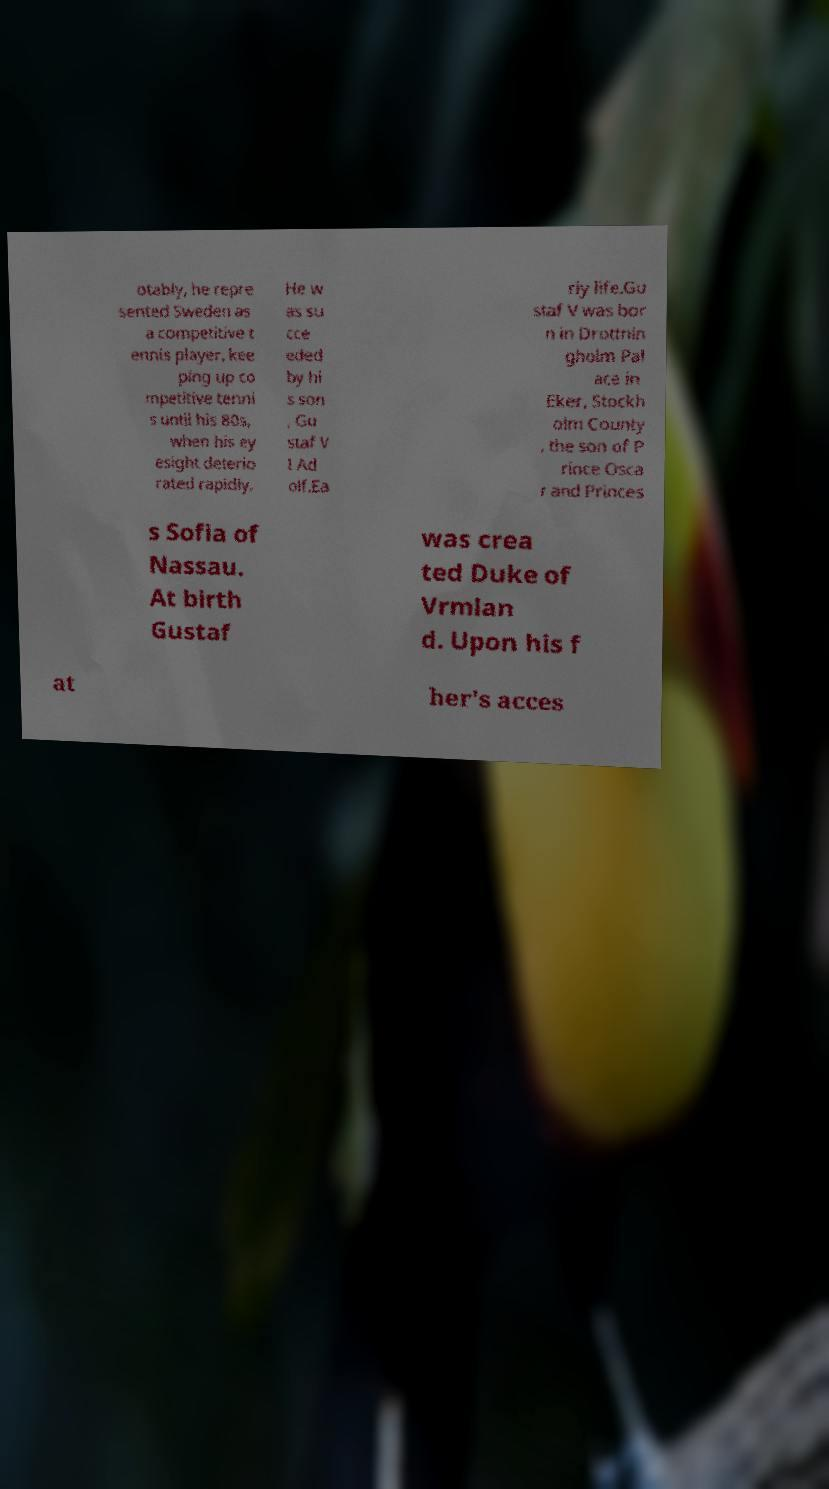What messages or text are displayed in this image? I need them in a readable, typed format. otably, he repre sented Sweden as a competitive t ennis player, kee ping up co mpetitive tenni s until his 80s, when his ey esight deterio rated rapidly. He w as su cce eded by hi s son , Gu staf V I Ad olf.Ea rly life.Gu staf V was bor n in Drottnin gholm Pal ace in Eker, Stockh olm County , the son of P rince Osca r and Princes s Sofia of Nassau. At birth Gustaf was crea ted Duke of Vrmlan d. Upon his f at her's acces 